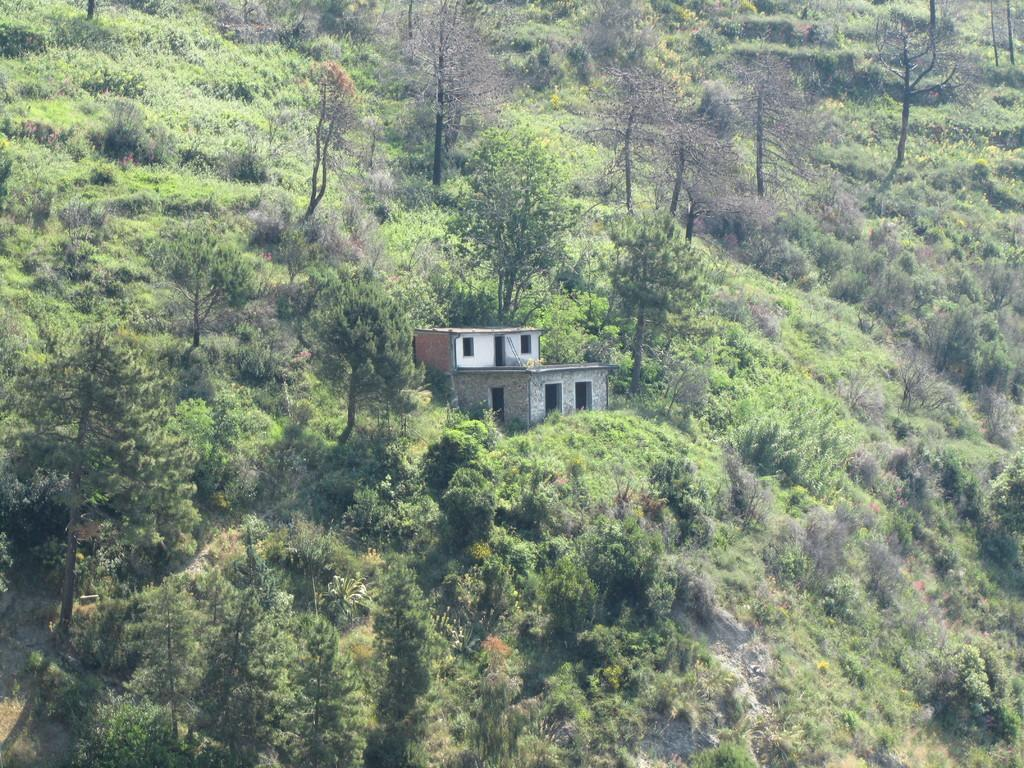What is the main feature of the image? There is a huge mountain in the image. What can be seen on the mountain? There are trees on the mountain. What colors do the trees have? The trees have various colors, including green, brown, ash, and black. What else is present in the image besides the mountain and trees? There is a building in the image. What colors are present on the building? The building has colors such as white, brown, and ash. Can you see a twig being used as a tool to help build the building in the image? There is no twig being used as a tool in the image; the focus is on the mountain, trees, and building. 